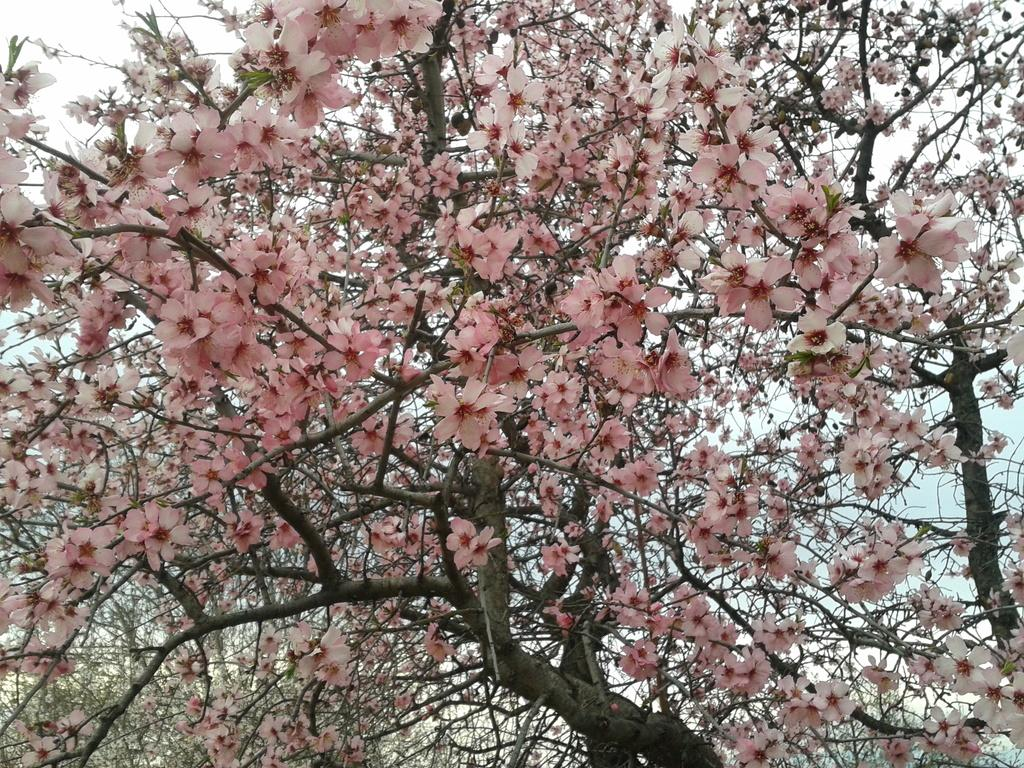What type of vegetation is present in the image? There are trees with flowers in the image. What can be seen in the background of the image? The sky is visible in the background of the image. What is the chance of finding a jail in the image? There is no mention of a jail in the image, so it cannot be determined if there is a chance of finding one. 